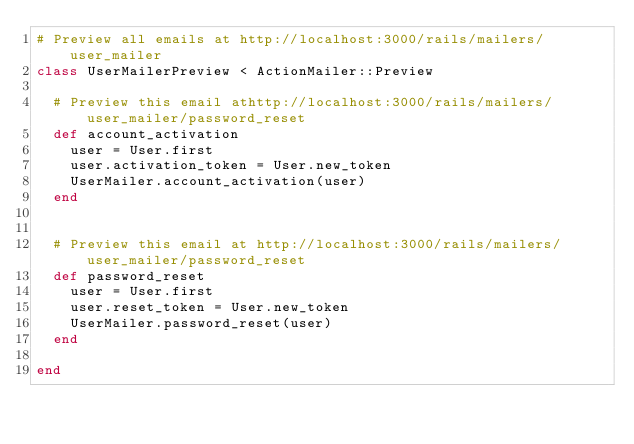Convert code to text. <code><loc_0><loc_0><loc_500><loc_500><_Ruby_># Preview all emails at http://localhost:3000/rails/mailers/user_mailer
class UserMailerPreview < ActionMailer::Preview

  # Preview this email athttp://localhost:3000/rails/mailers/user_mailer/password_reset
  def account_activation
    user = User.first
    user.activation_token = User.new_token
    UserMailer.account_activation(user)
  end


  # Preview this email at http://localhost:3000/rails/mailers/user_mailer/password_reset
  def password_reset
    user = User.first
    user.reset_token = User.new_token
    UserMailer.password_reset(user)
  end

end
</code> 